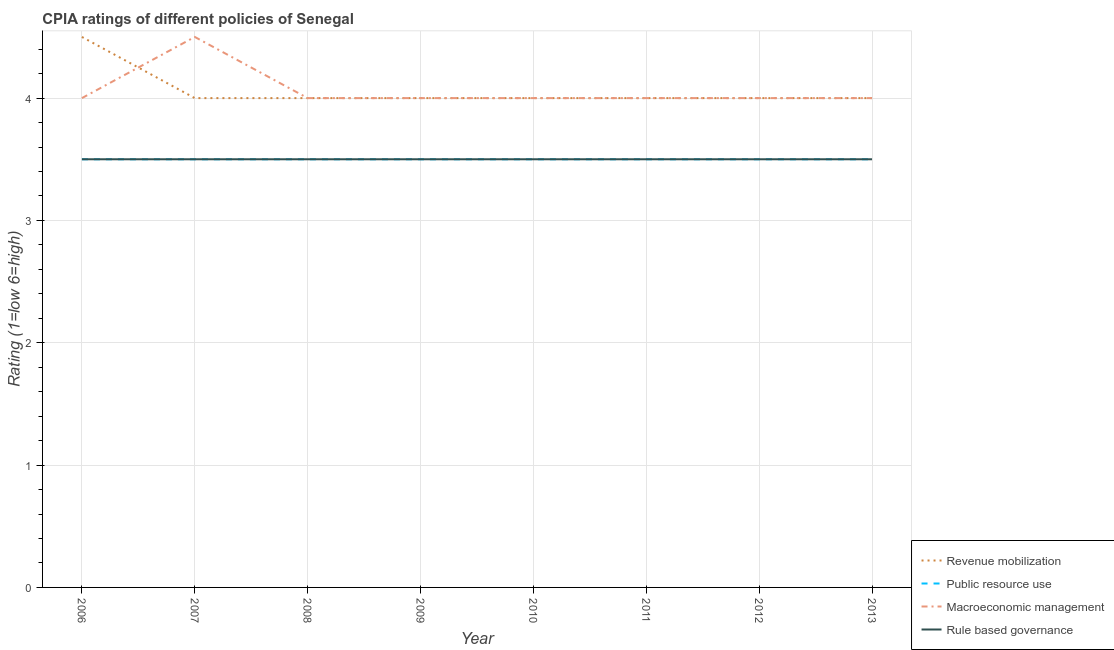How many different coloured lines are there?
Offer a terse response. 4. Does the line corresponding to cpia rating of public resource use intersect with the line corresponding to cpia rating of macroeconomic management?
Your answer should be compact. No. What is the cpia rating of macroeconomic management in 2009?
Provide a short and direct response. 4. Across all years, what is the maximum cpia rating of public resource use?
Your response must be concise. 3.5. In which year was the cpia rating of macroeconomic management maximum?
Offer a terse response. 2007. In which year was the cpia rating of public resource use minimum?
Keep it short and to the point. 2006. What is the average cpia rating of rule based governance per year?
Offer a very short reply. 3.5. In the year 2007, what is the difference between the cpia rating of macroeconomic management and cpia rating of revenue mobilization?
Keep it short and to the point. 0.5. Is the cpia rating of revenue mobilization in 2009 less than that in 2012?
Provide a short and direct response. No. Is the difference between the cpia rating of revenue mobilization in 2008 and 2009 greater than the difference between the cpia rating of rule based governance in 2008 and 2009?
Ensure brevity in your answer.  No. What is the difference between the highest and the second highest cpia rating of macroeconomic management?
Your answer should be very brief. 0.5. What is the difference between the highest and the lowest cpia rating of revenue mobilization?
Your answer should be very brief. 0.5. In how many years, is the cpia rating of revenue mobilization greater than the average cpia rating of revenue mobilization taken over all years?
Provide a short and direct response. 1. Is the sum of the cpia rating of rule based governance in 2007 and 2011 greater than the maximum cpia rating of macroeconomic management across all years?
Your response must be concise. Yes. Is it the case that in every year, the sum of the cpia rating of revenue mobilization and cpia rating of public resource use is greater than the cpia rating of macroeconomic management?
Keep it short and to the point. Yes. Does the cpia rating of revenue mobilization monotonically increase over the years?
Your response must be concise. No. Is the cpia rating of revenue mobilization strictly greater than the cpia rating of rule based governance over the years?
Provide a short and direct response. Yes. Is the cpia rating of revenue mobilization strictly less than the cpia rating of rule based governance over the years?
Give a very brief answer. No. Does the graph contain grids?
Keep it short and to the point. Yes. How many legend labels are there?
Provide a short and direct response. 4. What is the title of the graph?
Your answer should be compact. CPIA ratings of different policies of Senegal. Does "Quality of public administration" appear as one of the legend labels in the graph?
Make the answer very short. No. What is the Rating (1=low 6=high) in Macroeconomic management in 2006?
Give a very brief answer. 4. What is the Rating (1=low 6=high) of Rule based governance in 2006?
Your answer should be very brief. 3.5. What is the Rating (1=low 6=high) of Revenue mobilization in 2007?
Make the answer very short. 4. What is the Rating (1=low 6=high) in Macroeconomic management in 2007?
Ensure brevity in your answer.  4.5. What is the Rating (1=low 6=high) of Revenue mobilization in 2008?
Make the answer very short. 4. What is the Rating (1=low 6=high) in Rule based governance in 2008?
Keep it short and to the point. 3.5. What is the Rating (1=low 6=high) of Public resource use in 2009?
Give a very brief answer. 3.5. What is the Rating (1=low 6=high) in Macroeconomic management in 2009?
Keep it short and to the point. 4. What is the Rating (1=low 6=high) of Revenue mobilization in 2010?
Offer a very short reply. 4. What is the Rating (1=low 6=high) in Public resource use in 2011?
Provide a succinct answer. 3.5. What is the Rating (1=low 6=high) in Macroeconomic management in 2011?
Offer a very short reply. 4. What is the Rating (1=low 6=high) of Revenue mobilization in 2012?
Your answer should be very brief. 4. What is the Rating (1=low 6=high) in Public resource use in 2012?
Ensure brevity in your answer.  3.5. What is the Rating (1=low 6=high) of Rule based governance in 2012?
Keep it short and to the point. 3.5. What is the Rating (1=low 6=high) in Revenue mobilization in 2013?
Keep it short and to the point. 4. What is the Rating (1=low 6=high) in Rule based governance in 2013?
Provide a short and direct response. 3.5. Across all years, what is the maximum Rating (1=low 6=high) of Revenue mobilization?
Your response must be concise. 4.5. Across all years, what is the maximum Rating (1=low 6=high) of Public resource use?
Offer a very short reply. 3.5. Across all years, what is the maximum Rating (1=low 6=high) of Rule based governance?
Provide a short and direct response. 3.5. Across all years, what is the minimum Rating (1=low 6=high) in Revenue mobilization?
Your response must be concise. 4. Across all years, what is the minimum Rating (1=low 6=high) in Macroeconomic management?
Give a very brief answer. 4. What is the total Rating (1=low 6=high) of Revenue mobilization in the graph?
Offer a very short reply. 32.5. What is the total Rating (1=low 6=high) of Macroeconomic management in the graph?
Your answer should be very brief. 32.5. What is the difference between the Rating (1=low 6=high) of Public resource use in 2006 and that in 2007?
Make the answer very short. 0. What is the difference between the Rating (1=low 6=high) of Rule based governance in 2006 and that in 2007?
Offer a very short reply. 0. What is the difference between the Rating (1=low 6=high) in Revenue mobilization in 2006 and that in 2008?
Ensure brevity in your answer.  0.5. What is the difference between the Rating (1=low 6=high) in Public resource use in 2006 and that in 2008?
Offer a terse response. 0. What is the difference between the Rating (1=low 6=high) in Revenue mobilization in 2006 and that in 2009?
Offer a very short reply. 0.5. What is the difference between the Rating (1=low 6=high) in Public resource use in 2006 and that in 2009?
Provide a short and direct response. 0. What is the difference between the Rating (1=low 6=high) of Public resource use in 2006 and that in 2010?
Keep it short and to the point. 0. What is the difference between the Rating (1=low 6=high) in Macroeconomic management in 2006 and that in 2010?
Ensure brevity in your answer.  0. What is the difference between the Rating (1=low 6=high) of Revenue mobilization in 2006 and that in 2011?
Your answer should be compact. 0.5. What is the difference between the Rating (1=low 6=high) of Public resource use in 2006 and that in 2011?
Ensure brevity in your answer.  0. What is the difference between the Rating (1=low 6=high) of Public resource use in 2006 and that in 2012?
Give a very brief answer. 0. What is the difference between the Rating (1=low 6=high) in Rule based governance in 2006 and that in 2012?
Ensure brevity in your answer.  0. What is the difference between the Rating (1=low 6=high) of Revenue mobilization in 2006 and that in 2013?
Your answer should be compact. 0.5. What is the difference between the Rating (1=low 6=high) in Public resource use in 2006 and that in 2013?
Provide a succinct answer. 0. What is the difference between the Rating (1=low 6=high) in Macroeconomic management in 2006 and that in 2013?
Offer a very short reply. 0. What is the difference between the Rating (1=low 6=high) of Revenue mobilization in 2007 and that in 2008?
Provide a short and direct response. 0. What is the difference between the Rating (1=low 6=high) of Macroeconomic management in 2007 and that in 2008?
Your response must be concise. 0.5. What is the difference between the Rating (1=low 6=high) in Rule based governance in 2007 and that in 2008?
Keep it short and to the point. 0. What is the difference between the Rating (1=low 6=high) in Revenue mobilization in 2007 and that in 2009?
Keep it short and to the point. 0. What is the difference between the Rating (1=low 6=high) in Public resource use in 2007 and that in 2009?
Your answer should be very brief. 0. What is the difference between the Rating (1=low 6=high) in Revenue mobilization in 2007 and that in 2010?
Your answer should be very brief. 0. What is the difference between the Rating (1=low 6=high) in Public resource use in 2007 and that in 2010?
Ensure brevity in your answer.  0. What is the difference between the Rating (1=low 6=high) in Macroeconomic management in 2007 and that in 2010?
Offer a terse response. 0.5. What is the difference between the Rating (1=low 6=high) in Rule based governance in 2007 and that in 2010?
Provide a short and direct response. 0. What is the difference between the Rating (1=low 6=high) in Macroeconomic management in 2007 and that in 2011?
Give a very brief answer. 0.5. What is the difference between the Rating (1=low 6=high) of Rule based governance in 2007 and that in 2011?
Offer a terse response. 0. What is the difference between the Rating (1=low 6=high) of Revenue mobilization in 2007 and that in 2012?
Your response must be concise. 0. What is the difference between the Rating (1=low 6=high) in Public resource use in 2007 and that in 2012?
Ensure brevity in your answer.  0. What is the difference between the Rating (1=low 6=high) of Revenue mobilization in 2007 and that in 2013?
Make the answer very short. 0. What is the difference between the Rating (1=low 6=high) in Macroeconomic management in 2007 and that in 2013?
Provide a short and direct response. 0.5. What is the difference between the Rating (1=low 6=high) in Revenue mobilization in 2008 and that in 2009?
Make the answer very short. 0. What is the difference between the Rating (1=low 6=high) of Rule based governance in 2008 and that in 2009?
Offer a terse response. 0. What is the difference between the Rating (1=low 6=high) of Public resource use in 2008 and that in 2011?
Your answer should be very brief. 0. What is the difference between the Rating (1=low 6=high) of Rule based governance in 2008 and that in 2011?
Provide a succinct answer. 0. What is the difference between the Rating (1=low 6=high) in Revenue mobilization in 2008 and that in 2012?
Your answer should be compact. 0. What is the difference between the Rating (1=low 6=high) of Public resource use in 2008 and that in 2012?
Provide a succinct answer. 0. What is the difference between the Rating (1=low 6=high) in Revenue mobilization in 2009 and that in 2010?
Offer a terse response. 0. What is the difference between the Rating (1=low 6=high) of Public resource use in 2009 and that in 2010?
Make the answer very short. 0. What is the difference between the Rating (1=low 6=high) in Macroeconomic management in 2009 and that in 2010?
Make the answer very short. 0. What is the difference between the Rating (1=low 6=high) in Rule based governance in 2009 and that in 2010?
Offer a terse response. 0. What is the difference between the Rating (1=low 6=high) in Public resource use in 2009 and that in 2011?
Your answer should be compact. 0. What is the difference between the Rating (1=low 6=high) of Rule based governance in 2009 and that in 2011?
Make the answer very short. 0. What is the difference between the Rating (1=low 6=high) of Public resource use in 2009 and that in 2012?
Provide a succinct answer. 0. What is the difference between the Rating (1=low 6=high) of Public resource use in 2009 and that in 2013?
Keep it short and to the point. 0. What is the difference between the Rating (1=low 6=high) in Macroeconomic management in 2009 and that in 2013?
Your response must be concise. 0. What is the difference between the Rating (1=low 6=high) in Rule based governance in 2009 and that in 2013?
Offer a terse response. 0. What is the difference between the Rating (1=low 6=high) of Revenue mobilization in 2010 and that in 2011?
Provide a short and direct response. 0. What is the difference between the Rating (1=low 6=high) in Rule based governance in 2010 and that in 2011?
Offer a terse response. 0. What is the difference between the Rating (1=low 6=high) in Revenue mobilization in 2010 and that in 2012?
Your answer should be compact. 0. What is the difference between the Rating (1=low 6=high) in Macroeconomic management in 2010 and that in 2012?
Keep it short and to the point. 0. What is the difference between the Rating (1=low 6=high) of Revenue mobilization in 2010 and that in 2013?
Offer a terse response. 0. What is the difference between the Rating (1=low 6=high) in Public resource use in 2010 and that in 2013?
Offer a very short reply. 0. What is the difference between the Rating (1=low 6=high) of Rule based governance in 2010 and that in 2013?
Offer a terse response. 0. What is the difference between the Rating (1=low 6=high) in Macroeconomic management in 2011 and that in 2012?
Provide a short and direct response. 0. What is the difference between the Rating (1=low 6=high) in Revenue mobilization in 2011 and that in 2013?
Make the answer very short. 0. What is the difference between the Rating (1=low 6=high) in Public resource use in 2011 and that in 2013?
Provide a succinct answer. 0. What is the difference between the Rating (1=low 6=high) in Rule based governance in 2011 and that in 2013?
Your answer should be very brief. 0. What is the difference between the Rating (1=low 6=high) in Macroeconomic management in 2012 and that in 2013?
Offer a very short reply. 0. What is the difference between the Rating (1=low 6=high) of Revenue mobilization in 2006 and the Rating (1=low 6=high) of Public resource use in 2007?
Give a very brief answer. 1. What is the difference between the Rating (1=low 6=high) in Public resource use in 2006 and the Rating (1=low 6=high) in Macroeconomic management in 2007?
Your answer should be compact. -1. What is the difference between the Rating (1=low 6=high) of Public resource use in 2006 and the Rating (1=low 6=high) of Rule based governance in 2007?
Make the answer very short. 0. What is the difference between the Rating (1=low 6=high) in Macroeconomic management in 2006 and the Rating (1=low 6=high) in Rule based governance in 2007?
Your answer should be compact. 0.5. What is the difference between the Rating (1=low 6=high) in Revenue mobilization in 2006 and the Rating (1=low 6=high) in Rule based governance in 2008?
Provide a succinct answer. 1. What is the difference between the Rating (1=low 6=high) in Public resource use in 2006 and the Rating (1=low 6=high) in Rule based governance in 2008?
Keep it short and to the point. 0. What is the difference between the Rating (1=low 6=high) of Revenue mobilization in 2006 and the Rating (1=low 6=high) of Public resource use in 2009?
Keep it short and to the point. 1. What is the difference between the Rating (1=low 6=high) of Revenue mobilization in 2006 and the Rating (1=low 6=high) of Macroeconomic management in 2009?
Offer a terse response. 0.5. What is the difference between the Rating (1=low 6=high) of Revenue mobilization in 2006 and the Rating (1=low 6=high) of Rule based governance in 2009?
Keep it short and to the point. 1. What is the difference between the Rating (1=low 6=high) of Public resource use in 2006 and the Rating (1=low 6=high) of Rule based governance in 2009?
Provide a succinct answer. 0. What is the difference between the Rating (1=low 6=high) of Revenue mobilization in 2006 and the Rating (1=low 6=high) of Public resource use in 2010?
Provide a short and direct response. 1. What is the difference between the Rating (1=low 6=high) of Revenue mobilization in 2006 and the Rating (1=low 6=high) of Rule based governance in 2010?
Provide a succinct answer. 1. What is the difference between the Rating (1=low 6=high) in Public resource use in 2006 and the Rating (1=low 6=high) in Macroeconomic management in 2010?
Provide a short and direct response. -0.5. What is the difference between the Rating (1=low 6=high) of Public resource use in 2006 and the Rating (1=low 6=high) of Rule based governance in 2011?
Provide a short and direct response. 0. What is the difference between the Rating (1=low 6=high) of Revenue mobilization in 2006 and the Rating (1=low 6=high) of Public resource use in 2012?
Keep it short and to the point. 1. What is the difference between the Rating (1=low 6=high) of Public resource use in 2006 and the Rating (1=low 6=high) of Macroeconomic management in 2012?
Ensure brevity in your answer.  -0.5. What is the difference between the Rating (1=low 6=high) in Revenue mobilization in 2006 and the Rating (1=low 6=high) in Macroeconomic management in 2013?
Offer a very short reply. 0.5. What is the difference between the Rating (1=low 6=high) of Public resource use in 2006 and the Rating (1=low 6=high) of Macroeconomic management in 2013?
Your response must be concise. -0.5. What is the difference between the Rating (1=low 6=high) of Macroeconomic management in 2006 and the Rating (1=low 6=high) of Rule based governance in 2013?
Offer a terse response. 0.5. What is the difference between the Rating (1=low 6=high) of Public resource use in 2007 and the Rating (1=low 6=high) of Macroeconomic management in 2008?
Your answer should be compact. -0.5. What is the difference between the Rating (1=low 6=high) in Macroeconomic management in 2007 and the Rating (1=low 6=high) in Rule based governance in 2008?
Keep it short and to the point. 1. What is the difference between the Rating (1=low 6=high) in Revenue mobilization in 2007 and the Rating (1=low 6=high) in Public resource use in 2009?
Your answer should be very brief. 0.5. What is the difference between the Rating (1=low 6=high) of Revenue mobilization in 2007 and the Rating (1=low 6=high) of Rule based governance in 2009?
Your answer should be very brief. 0.5. What is the difference between the Rating (1=low 6=high) in Public resource use in 2007 and the Rating (1=low 6=high) in Rule based governance in 2009?
Offer a terse response. 0. What is the difference between the Rating (1=low 6=high) of Macroeconomic management in 2007 and the Rating (1=low 6=high) of Rule based governance in 2009?
Your answer should be very brief. 1. What is the difference between the Rating (1=low 6=high) of Public resource use in 2007 and the Rating (1=low 6=high) of Rule based governance in 2010?
Your response must be concise. 0. What is the difference between the Rating (1=low 6=high) in Public resource use in 2007 and the Rating (1=low 6=high) in Macroeconomic management in 2011?
Offer a terse response. -0.5. What is the difference between the Rating (1=low 6=high) in Revenue mobilization in 2007 and the Rating (1=low 6=high) in Macroeconomic management in 2012?
Your answer should be compact. 0. What is the difference between the Rating (1=low 6=high) in Public resource use in 2007 and the Rating (1=low 6=high) in Macroeconomic management in 2012?
Ensure brevity in your answer.  -0.5. What is the difference between the Rating (1=low 6=high) of Public resource use in 2007 and the Rating (1=low 6=high) of Rule based governance in 2012?
Your answer should be compact. 0. What is the difference between the Rating (1=low 6=high) of Macroeconomic management in 2007 and the Rating (1=low 6=high) of Rule based governance in 2012?
Make the answer very short. 1. What is the difference between the Rating (1=low 6=high) in Revenue mobilization in 2007 and the Rating (1=low 6=high) in Public resource use in 2013?
Provide a succinct answer. 0.5. What is the difference between the Rating (1=low 6=high) of Revenue mobilization in 2007 and the Rating (1=low 6=high) of Macroeconomic management in 2013?
Your answer should be very brief. 0. What is the difference between the Rating (1=low 6=high) of Revenue mobilization in 2007 and the Rating (1=low 6=high) of Rule based governance in 2013?
Your response must be concise. 0.5. What is the difference between the Rating (1=low 6=high) in Macroeconomic management in 2007 and the Rating (1=low 6=high) in Rule based governance in 2013?
Make the answer very short. 1. What is the difference between the Rating (1=low 6=high) of Revenue mobilization in 2008 and the Rating (1=low 6=high) of Rule based governance in 2009?
Offer a very short reply. 0.5. What is the difference between the Rating (1=low 6=high) of Revenue mobilization in 2008 and the Rating (1=low 6=high) of Public resource use in 2010?
Offer a terse response. 0.5. What is the difference between the Rating (1=low 6=high) in Revenue mobilization in 2008 and the Rating (1=low 6=high) in Macroeconomic management in 2010?
Provide a short and direct response. 0. What is the difference between the Rating (1=low 6=high) in Revenue mobilization in 2008 and the Rating (1=low 6=high) in Rule based governance in 2010?
Give a very brief answer. 0.5. What is the difference between the Rating (1=low 6=high) in Macroeconomic management in 2008 and the Rating (1=low 6=high) in Rule based governance in 2010?
Offer a terse response. 0.5. What is the difference between the Rating (1=low 6=high) in Revenue mobilization in 2008 and the Rating (1=low 6=high) in Rule based governance in 2011?
Keep it short and to the point. 0.5. What is the difference between the Rating (1=low 6=high) of Macroeconomic management in 2008 and the Rating (1=low 6=high) of Rule based governance in 2011?
Your answer should be very brief. 0.5. What is the difference between the Rating (1=low 6=high) in Revenue mobilization in 2008 and the Rating (1=low 6=high) in Public resource use in 2012?
Ensure brevity in your answer.  0.5. What is the difference between the Rating (1=low 6=high) in Revenue mobilization in 2008 and the Rating (1=low 6=high) in Macroeconomic management in 2012?
Provide a succinct answer. 0. What is the difference between the Rating (1=low 6=high) of Public resource use in 2008 and the Rating (1=low 6=high) of Macroeconomic management in 2012?
Your answer should be very brief. -0.5. What is the difference between the Rating (1=low 6=high) of Public resource use in 2008 and the Rating (1=low 6=high) of Rule based governance in 2012?
Make the answer very short. 0. What is the difference between the Rating (1=low 6=high) in Revenue mobilization in 2008 and the Rating (1=low 6=high) in Macroeconomic management in 2013?
Provide a succinct answer. 0. What is the difference between the Rating (1=low 6=high) of Public resource use in 2008 and the Rating (1=low 6=high) of Macroeconomic management in 2013?
Your answer should be very brief. -0.5. What is the difference between the Rating (1=low 6=high) in Revenue mobilization in 2009 and the Rating (1=low 6=high) in Rule based governance in 2010?
Offer a terse response. 0.5. What is the difference between the Rating (1=low 6=high) of Public resource use in 2009 and the Rating (1=low 6=high) of Macroeconomic management in 2010?
Make the answer very short. -0.5. What is the difference between the Rating (1=low 6=high) of Public resource use in 2009 and the Rating (1=low 6=high) of Rule based governance in 2010?
Keep it short and to the point. 0. What is the difference between the Rating (1=low 6=high) in Revenue mobilization in 2009 and the Rating (1=low 6=high) in Public resource use in 2011?
Provide a succinct answer. 0.5. What is the difference between the Rating (1=low 6=high) of Revenue mobilization in 2009 and the Rating (1=low 6=high) of Macroeconomic management in 2011?
Offer a terse response. 0. What is the difference between the Rating (1=low 6=high) in Public resource use in 2009 and the Rating (1=low 6=high) in Rule based governance in 2011?
Provide a short and direct response. 0. What is the difference between the Rating (1=low 6=high) of Revenue mobilization in 2009 and the Rating (1=low 6=high) of Rule based governance in 2012?
Provide a succinct answer. 0.5. What is the difference between the Rating (1=low 6=high) of Public resource use in 2009 and the Rating (1=low 6=high) of Rule based governance in 2012?
Make the answer very short. 0. What is the difference between the Rating (1=low 6=high) in Revenue mobilization in 2009 and the Rating (1=low 6=high) in Rule based governance in 2013?
Keep it short and to the point. 0.5. What is the difference between the Rating (1=low 6=high) of Public resource use in 2009 and the Rating (1=low 6=high) of Macroeconomic management in 2013?
Provide a succinct answer. -0.5. What is the difference between the Rating (1=low 6=high) in Public resource use in 2009 and the Rating (1=low 6=high) in Rule based governance in 2013?
Provide a succinct answer. 0. What is the difference between the Rating (1=low 6=high) of Revenue mobilization in 2010 and the Rating (1=low 6=high) of Macroeconomic management in 2011?
Offer a terse response. 0. What is the difference between the Rating (1=low 6=high) in Macroeconomic management in 2010 and the Rating (1=low 6=high) in Rule based governance in 2011?
Ensure brevity in your answer.  0.5. What is the difference between the Rating (1=low 6=high) in Revenue mobilization in 2010 and the Rating (1=low 6=high) in Public resource use in 2012?
Provide a succinct answer. 0.5. What is the difference between the Rating (1=low 6=high) in Revenue mobilization in 2010 and the Rating (1=low 6=high) in Rule based governance in 2012?
Your answer should be very brief. 0.5. What is the difference between the Rating (1=low 6=high) of Public resource use in 2010 and the Rating (1=low 6=high) of Macroeconomic management in 2012?
Provide a succinct answer. -0.5. What is the difference between the Rating (1=low 6=high) of Macroeconomic management in 2010 and the Rating (1=low 6=high) of Rule based governance in 2012?
Offer a terse response. 0.5. What is the difference between the Rating (1=low 6=high) in Revenue mobilization in 2010 and the Rating (1=low 6=high) in Public resource use in 2013?
Your answer should be very brief. 0.5. What is the difference between the Rating (1=low 6=high) of Public resource use in 2010 and the Rating (1=low 6=high) of Macroeconomic management in 2013?
Provide a short and direct response. -0.5. What is the difference between the Rating (1=low 6=high) in Public resource use in 2010 and the Rating (1=low 6=high) in Rule based governance in 2013?
Your answer should be very brief. 0. What is the difference between the Rating (1=low 6=high) of Macroeconomic management in 2010 and the Rating (1=low 6=high) of Rule based governance in 2013?
Offer a very short reply. 0.5. What is the difference between the Rating (1=low 6=high) of Revenue mobilization in 2011 and the Rating (1=low 6=high) of Public resource use in 2012?
Keep it short and to the point. 0.5. What is the difference between the Rating (1=low 6=high) of Revenue mobilization in 2011 and the Rating (1=low 6=high) of Macroeconomic management in 2012?
Provide a succinct answer. 0. What is the difference between the Rating (1=low 6=high) in Revenue mobilization in 2011 and the Rating (1=low 6=high) in Macroeconomic management in 2013?
Your answer should be very brief. 0. What is the difference between the Rating (1=low 6=high) of Revenue mobilization in 2011 and the Rating (1=low 6=high) of Rule based governance in 2013?
Ensure brevity in your answer.  0.5. What is the difference between the Rating (1=low 6=high) in Public resource use in 2011 and the Rating (1=low 6=high) in Rule based governance in 2013?
Your answer should be compact. 0. What is the difference between the Rating (1=low 6=high) of Macroeconomic management in 2011 and the Rating (1=low 6=high) of Rule based governance in 2013?
Give a very brief answer. 0.5. What is the difference between the Rating (1=low 6=high) of Revenue mobilization in 2012 and the Rating (1=low 6=high) of Rule based governance in 2013?
Your response must be concise. 0.5. What is the difference between the Rating (1=low 6=high) of Macroeconomic management in 2012 and the Rating (1=low 6=high) of Rule based governance in 2013?
Offer a terse response. 0.5. What is the average Rating (1=low 6=high) of Revenue mobilization per year?
Offer a very short reply. 4.06. What is the average Rating (1=low 6=high) in Public resource use per year?
Ensure brevity in your answer.  3.5. What is the average Rating (1=low 6=high) of Macroeconomic management per year?
Keep it short and to the point. 4.06. What is the average Rating (1=low 6=high) in Rule based governance per year?
Provide a succinct answer. 3.5. In the year 2006, what is the difference between the Rating (1=low 6=high) in Revenue mobilization and Rating (1=low 6=high) in Public resource use?
Offer a very short reply. 1. In the year 2006, what is the difference between the Rating (1=low 6=high) of Revenue mobilization and Rating (1=low 6=high) of Macroeconomic management?
Your response must be concise. 0.5. In the year 2006, what is the difference between the Rating (1=low 6=high) in Revenue mobilization and Rating (1=low 6=high) in Rule based governance?
Make the answer very short. 1. In the year 2006, what is the difference between the Rating (1=low 6=high) in Public resource use and Rating (1=low 6=high) in Rule based governance?
Ensure brevity in your answer.  0. In the year 2006, what is the difference between the Rating (1=low 6=high) in Macroeconomic management and Rating (1=low 6=high) in Rule based governance?
Your response must be concise. 0.5. In the year 2007, what is the difference between the Rating (1=low 6=high) in Revenue mobilization and Rating (1=low 6=high) in Rule based governance?
Give a very brief answer. 0.5. In the year 2007, what is the difference between the Rating (1=low 6=high) in Public resource use and Rating (1=low 6=high) in Macroeconomic management?
Provide a short and direct response. -1. In the year 2007, what is the difference between the Rating (1=low 6=high) of Public resource use and Rating (1=low 6=high) of Rule based governance?
Your answer should be compact. 0. In the year 2008, what is the difference between the Rating (1=low 6=high) in Revenue mobilization and Rating (1=low 6=high) in Public resource use?
Provide a succinct answer. 0.5. In the year 2008, what is the difference between the Rating (1=low 6=high) in Revenue mobilization and Rating (1=low 6=high) in Macroeconomic management?
Offer a very short reply. 0. In the year 2008, what is the difference between the Rating (1=low 6=high) in Revenue mobilization and Rating (1=low 6=high) in Rule based governance?
Provide a succinct answer. 0.5. In the year 2008, what is the difference between the Rating (1=low 6=high) of Public resource use and Rating (1=low 6=high) of Rule based governance?
Keep it short and to the point. 0. In the year 2009, what is the difference between the Rating (1=low 6=high) of Revenue mobilization and Rating (1=low 6=high) of Public resource use?
Offer a very short reply. 0.5. In the year 2009, what is the difference between the Rating (1=low 6=high) in Revenue mobilization and Rating (1=low 6=high) in Macroeconomic management?
Your answer should be very brief. 0. In the year 2009, what is the difference between the Rating (1=low 6=high) in Public resource use and Rating (1=low 6=high) in Macroeconomic management?
Make the answer very short. -0.5. In the year 2009, what is the difference between the Rating (1=low 6=high) in Public resource use and Rating (1=low 6=high) in Rule based governance?
Keep it short and to the point. 0. In the year 2009, what is the difference between the Rating (1=low 6=high) of Macroeconomic management and Rating (1=low 6=high) of Rule based governance?
Provide a succinct answer. 0.5. In the year 2010, what is the difference between the Rating (1=low 6=high) of Revenue mobilization and Rating (1=low 6=high) of Public resource use?
Offer a terse response. 0.5. In the year 2010, what is the difference between the Rating (1=low 6=high) of Revenue mobilization and Rating (1=low 6=high) of Rule based governance?
Offer a terse response. 0.5. In the year 2010, what is the difference between the Rating (1=low 6=high) of Public resource use and Rating (1=low 6=high) of Macroeconomic management?
Your answer should be compact. -0.5. In the year 2010, what is the difference between the Rating (1=low 6=high) in Public resource use and Rating (1=low 6=high) in Rule based governance?
Offer a terse response. 0. In the year 2011, what is the difference between the Rating (1=low 6=high) of Revenue mobilization and Rating (1=low 6=high) of Macroeconomic management?
Provide a short and direct response. 0. In the year 2011, what is the difference between the Rating (1=low 6=high) of Public resource use and Rating (1=low 6=high) of Macroeconomic management?
Give a very brief answer. -0.5. In the year 2011, what is the difference between the Rating (1=low 6=high) of Public resource use and Rating (1=low 6=high) of Rule based governance?
Keep it short and to the point. 0. In the year 2012, what is the difference between the Rating (1=low 6=high) in Revenue mobilization and Rating (1=low 6=high) in Macroeconomic management?
Keep it short and to the point. 0. In the year 2012, what is the difference between the Rating (1=low 6=high) in Revenue mobilization and Rating (1=low 6=high) in Rule based governance?
Ensure brevity in your answer.  0.5. In the year 2013, what is the difference between the Rating (1=low 6=high) in Revenue mobilization and Rating (1=low 6=high) in Public resource use?
Ensure brevity in your answer.  0.5. In the year 2013, what is the difference between the Rating (1=low 6=high) in Revenue mobilization and Rating (1=low 6=high) in Macroeconomic management?
Keep it short and to the point. 0. In the year 2013, what is the difference between the Rating (1=low 6=high) in Macroeconomic management and Rating (1=low 6=high) in Rule based governance?
Your answer should be compact. 0.5. What is the ratio of the Rating (1=low 6=high) in Revenue mobilization in 2006 to that in 2007?
Provide a succinct answer. 1.12. What is the ratio of the Rating (1=low 6=high) in Public resource use in 2006 to that in 2007?
Provide a succinct answer. 1. What is the ratio of the Rating (1=low 6=high) of Macroeconomic management in 2006 to that in 2007?
Give a very brief answer. 0.89. What is the ratio of the Rating (1=low 6=high) in Public resource use in 2006 to that in 2008?
Offer a very short reply. 1. What is the ratio of the Rating (1=low 6=high) in Revenue mobilization in 2006 to that in 2009?
Your answer should be very brief. 1.12. What is the ratio of the Rating (1=low 6=high) in Public resource use in 2006 to that in 2009?
Provide a succinct answer. 1. What is the ratio of the Rating (1=low 6=high) of Public resource use in 2006 to that in 2010?
Ensure brevity in your answer.  1. What is the ratio of the Rating (1=low 6=high) of Macroeconomic management in 2006 to that in 2011?
Your answer should be compact. 1. What is the ratio of the Rating (1=low 6=high) of Revenue mobilization in 2006 to that in 2012?
Provide a short and direct response. 1.12. What is the ratio of the Rating (1=low 6=high) of Public resource use in 2006 to that in 2012?
Offer a terse response. 1. What is the ratio of the Rating (1=low 6=high) in Macroeconomic management in 2006 to that in 2012?
Provide a short and direct response. 1. What is the ratio of the Rating (1=low 6=high) of Rule based governance in 2006 to that in 2012?
Your response must be concise. 1. What is the ratio of the Rating (1=low 6=high) of Public resource use in 2006 to that in 2013?
Make the answer very short. 1. What is the ratio of the Rating (1=low 6=high) in Revenue mobilization in 2007 to that in 2008?
Offer a terse response. 1. What is the ratio of the Rating (1=low 6=high) of Public resource use in 2007 to that in 2008?
Your answer should be very brief. 1. What is the ratio of the Rating (1=low 6=high) in Macroeconomic management in 2007 to that in 2008?
Your answer should be very brief. 1.12. What is the ratio of the Rating (1=low 6=high) of Rule based governance in 2007 to that in 2008?
Keep it short and to the point. 1. What is the ratio of the Rating (1=low 6=high) of Public resource use in 2007 to that in 2009?
Ensure brevity in your answer.  1. What is the ratio of the Rating (1=low 6=high) of Macroeconomic management in 2007 to that in 2009?
Provide a short and direct response. 1.12. What is the ratio of the Rating (1=low 6=high) of Rule based governance in 2007 to that in 2009?
Offer a terse response. 1. What is the ratio of the Rating (1=low 6=high) of Revenue mobilization in 2007 to that in 2010?
Provide a succinct answer. 1. What is the ratio of the Rating (1=low 6=high) of Public resource use in 2007 to that in 2010?
Your answer should be compact. 1. What is the ratio of the Rating (1=low 6=high) in Macroeconomic management in 2007 to that in 2010?
Offer a terse response. 1.12. What is the ratio of the Rating (1=low 6=high) of Revenue mobilization in 2007 to that in 2011?
Keep it short and to the point. 1. What is the ratio of the Rating (1=low 6=high) in Public resource use in 2007 to that in 2011?
Offer a terse response. 1. What is the ratio of the Rating (1=low 6=high) of Macroeconomic management in 2007 to that in 2011?
Provide a short and direct response. 1.12. What is the ratio of the Rating (1=low 6=high) in Rule based governance in 2007 to that in 2011?
Make the answer very short. 1. What is the ratio of the Rating (1=low 6=high) of Public resource use in 2007 to that in 2012?
Provide a succinct answer. 1. What is the ratio of the Rating (1=low 6=high) of Public resource use in 2007 to that in 2013?
Make the answer very short. 1. What is the ratio of the Rating (1=low 6=high) in Macroeconomic management in 2007 to that in 2013?
Provide a succinct answer. 1.12. What is the ratio of the Rating (1=low 6=high) of Rule based governance in 2008 to that in 2009?
Your response must be concise. 1. What is the ratio of the Rating (1=low 6=high) in Public resource use in 2008 to that in 2010?
Keep it short and to the point. 1. What is the ratio of the Rating (1=low 6=high) of Macroeconomic management in 2008 to that in 2011?
Keep it short and to the point. 1. What is the ratio of the Rating (1=low 6=high) in Revenue mobilization in 2008 to that in 2012?
Give a very brief answer. 1. What is the ratio of the Rating (1=low 6=high) of Public resource use in 2008 to that in 2012?
Make the answer very short. 1. What is the ratio of the Rating (1=low 6=high) in Macroeconomic management in 2008 to that in 2012?
Provide a short and direct response. 1. What is the ratio of the Rating (1=low 6=high) of Rule based governance in 2008 to that in 2012?
Your response must be concise. 1. What is the ratio of the Rating (1=low 6=high) in Rule based governance in 2008 to that in 2013?
Provide a succinct answer. 1. What is the ratio of the Rating (1=low 6=high) of Revenue mobilization in 2009 to that in 2010?
Your answer should be very brief. 1. What is the ratio of the Rating (1=low 6=high) in Revenue mobilization in 2009 to that in 2011?
Keep it short and to the point. 1. What is the ratio of the Rating (1=low 6=high) of Public resource use in 2009 to that in 2011?
Your answer should be very brief. 1. What is the ratio of the Rating (1=low 6=high) of Macroeconomic management in 2009 to that in 2011?
Keep it short and to the point. 1. What is the ratio of the Rating (1=low 6=high) of Public resource use in 2009 to that in 2012?
Provide a succinct answer. 1. What is the ratio of the Rating (1=low 6=high) of Macroeconomic management in 2009 to that in 2012?
Offer a very short reply. 1. What is the ratio of the Rating (1=low 6=high) in Public resource use in 2010 to that in 2011?
Provide a short and direct response. 1. What is the ratio of the Rating (1=low 6=high) of Macroeconomic management in 2010 to that in 2011?
Keep it short and to the point. 1. What is the ratio of the Rating (1=low 6=high) in Rule based governance in 2010 to that in 2011?
Your response must be concise. 1. What is the ratio of the Rating (1=low 6=high) in Revenue mobilization in 2010 to that in 2012?
Your response must be concise. 1. What is the ratio of the Rating (1=low 6=high) of Macroeconomic management in 2010 to that in 2012?
Provide a short and direct response. 1. What is the ratio of the Rating (1=low 6=high) of Rule based governance in 2010 to that in 2012?
Your answer should be compact. 1. What is the ratio of the Rating (1=low 6=high) in Rule based governance in 2010 to that in 2013?
Ensure brevity in your answer.  1. What is the ratio of the Rating (1=low 6=high) of Rule based governance in 2011 to that in 2012?
Your response must be concise. 1. What is the ratio of the Rating (1=low 6=high) in Revenue mobilization in 2011 to that in 2013?
Make the answer very short. 1. What is the ratio of the Rating (1=low 6=high) in Public resource use in 2011 to that in 2013?
Offer a terse response. 1. What is the ratio of the Rating (1=low 6=high) in Macroeconomic management in 2011 to that in 2013?
Your response must be concise. 1. What is the ratio of the Rating (1=low 6=high) in Rule based governance in 2011 to that in 2013?
Keep it short and to the point. 1. What is the ratio of the Rating (1=low 6=high) of Revenue mobilization in 2012 to that in 2013?
Give a very brief answer. 1. What is the ratio of the Rating (1=low 6=high) in Macroeconomic management in 2012 to that in 2013?
Keep it short and to the point. 1. What is the ratio of the Rating (1=low 6=high) of Rule based governance in 2012 to that in 2013?
Your response must be concise. 1. What is the difference between the highest and the second highest Rating (1=low 6=high) in Revenue mobilization?
Provide a succinct answer. 0.5. What is the difference between the highest and the second highest Rating (1=low 6=high) of Public resource use?
Give a very brief answer. 0. What is the difference between the highest and the lowest Rating (1=low 6=high) in Revenue mobilization?
Provide a succinct answer. 0.5. What is the difference between the highest and the lowest Rating (1=low 6=high) of Public resource use?
Ensure brevity in your answer.  0. 